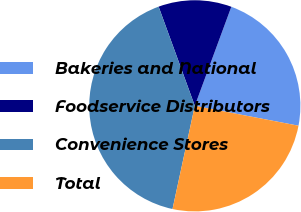Convert chart to OTSL. <chart><loc_0><loc_0><loc_500><loc_500><pie_chart><fcel>Bakeries and National<fcel>Foodservice Distributors<fcel>Convenience Stores<fcel>Total<nl><fcel>22.39%<fcel>11.19%<fcel>41.04%<fcel>25.37%<nl></chart> 